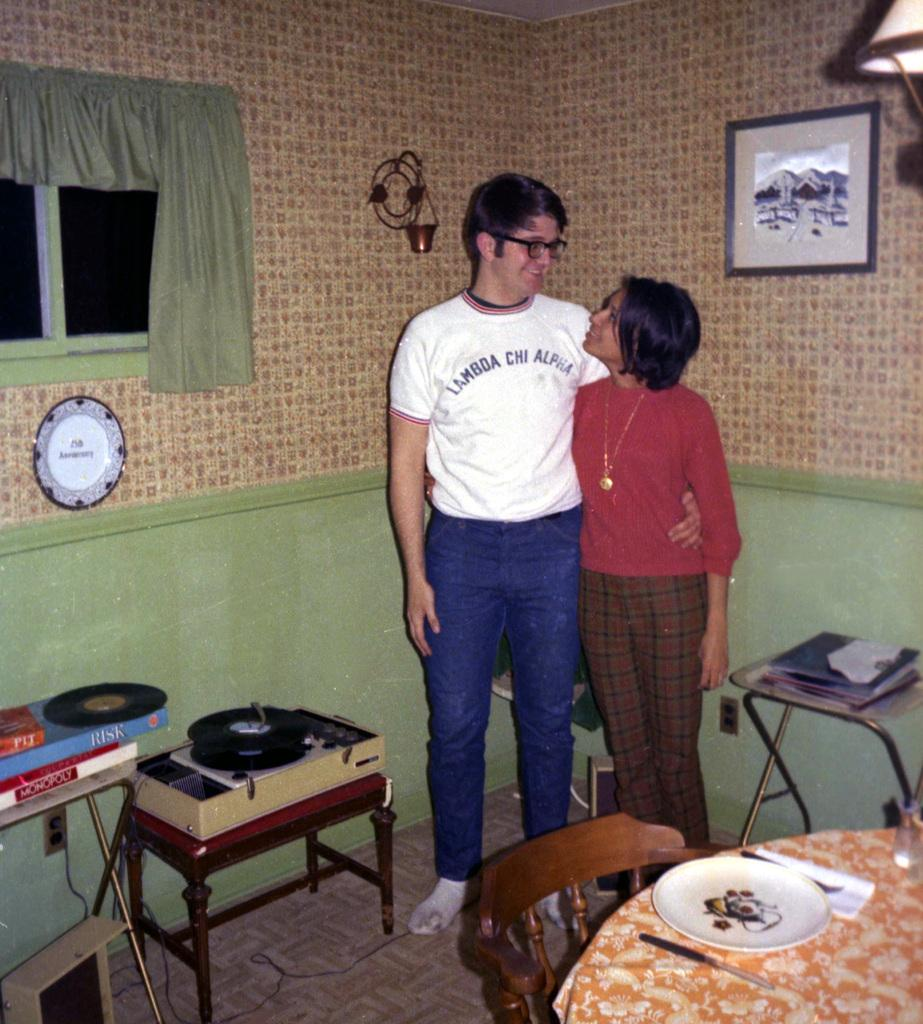<image>
Write a terse but informative summary of the picture. A couple in a kitchen with the man having lambda chi alpha on his shirt 